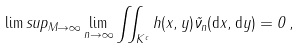<formula> <loc_0><loc_0><loc_500><loc_500>\lim s u p _ { M \to \infty } \lim _ { n \to \infty } \iint _ { K ^ { c } } h ( x , y ) \tilde { \nu } _ { n } ( \mathrm d x , \mathrm d y ) = 0 \, ,</formula> 